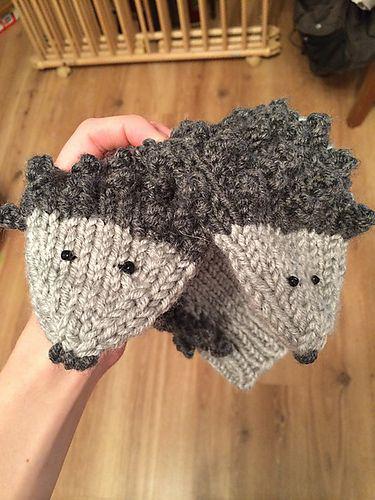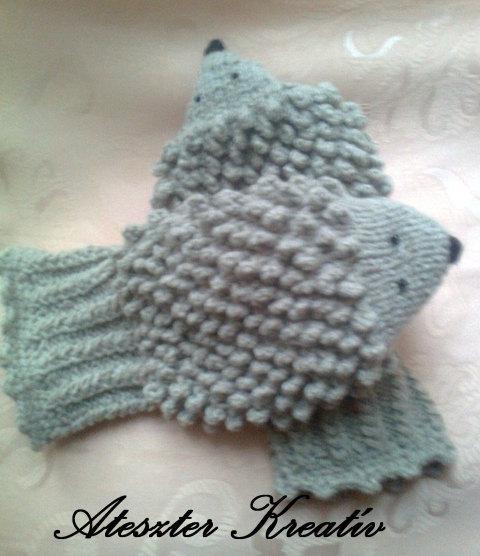The first image is the image on the left, the second image is the image on the right. Assess this claim about the two images: "human hands are visible". Correct or not? Answer yes or no. Yes. 